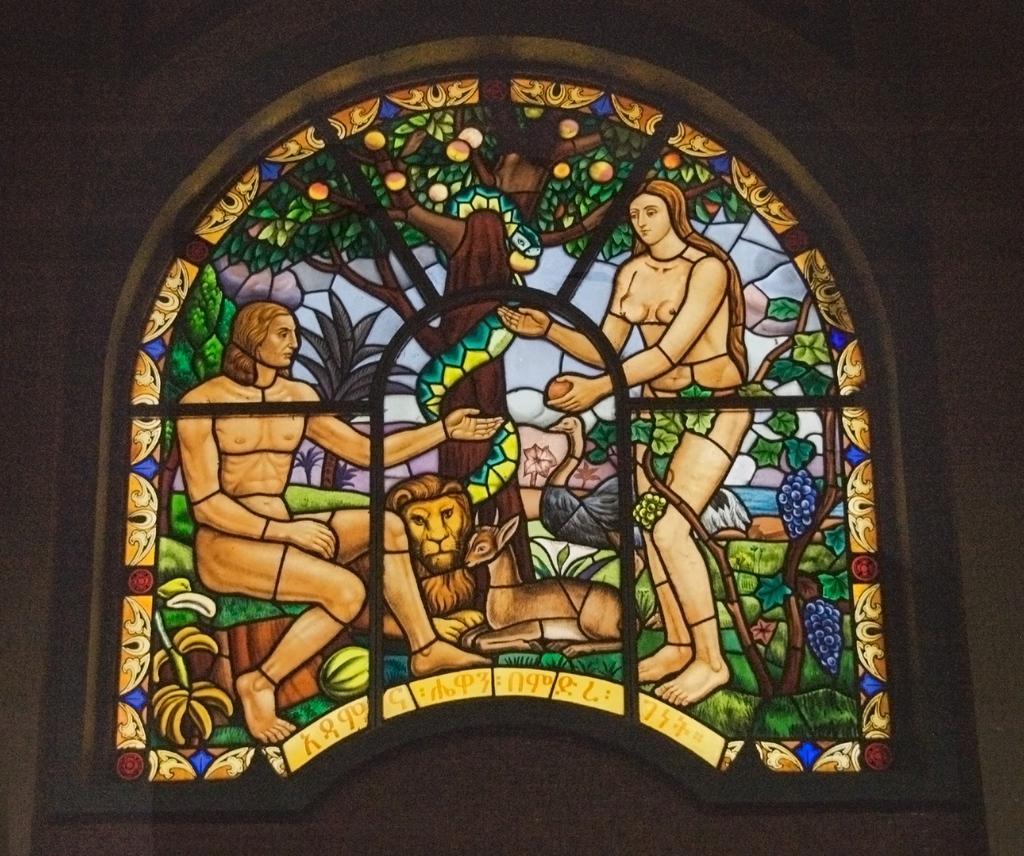In one or two sentences, can you explain what this image depicts? This image consists of a painting made on the glass. It consists of two persons, lion, deer, and a tree. It looks like a window of a building. 